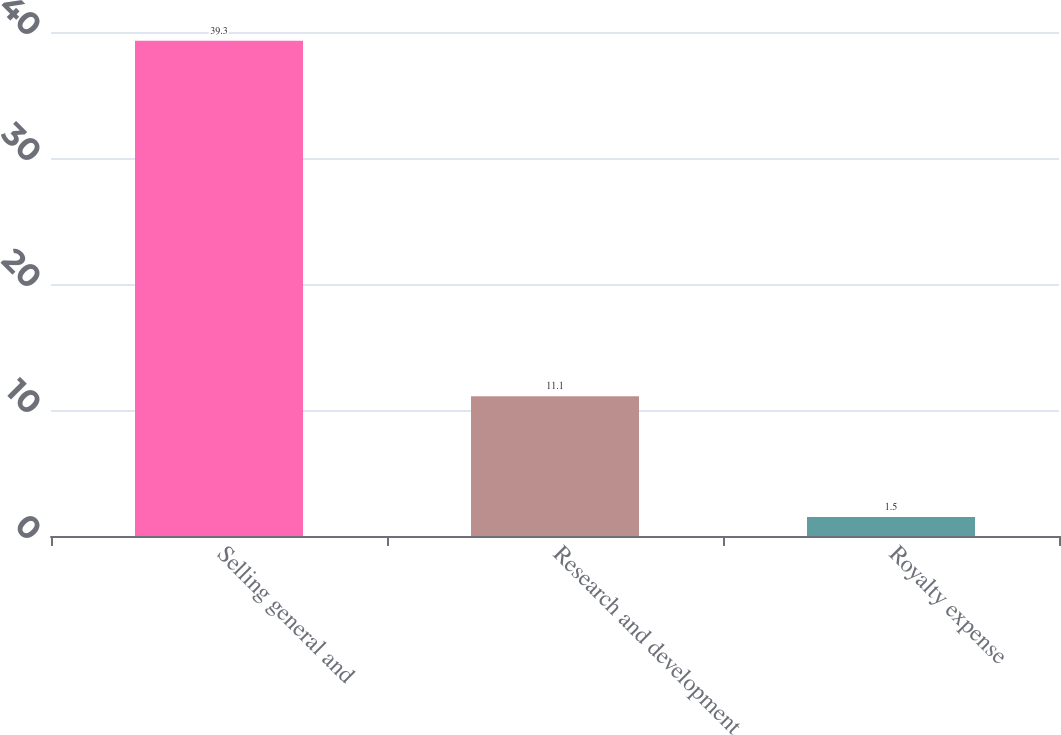<chart> <loc_0><loc_0><loc_500><loc_500><bar_chart><fcel>Selling general and<fcel>Research and development<fcel>Royalty expense<nl><fcel>39.3<fcel>11.1<fcel>1.5<nl></chart> 